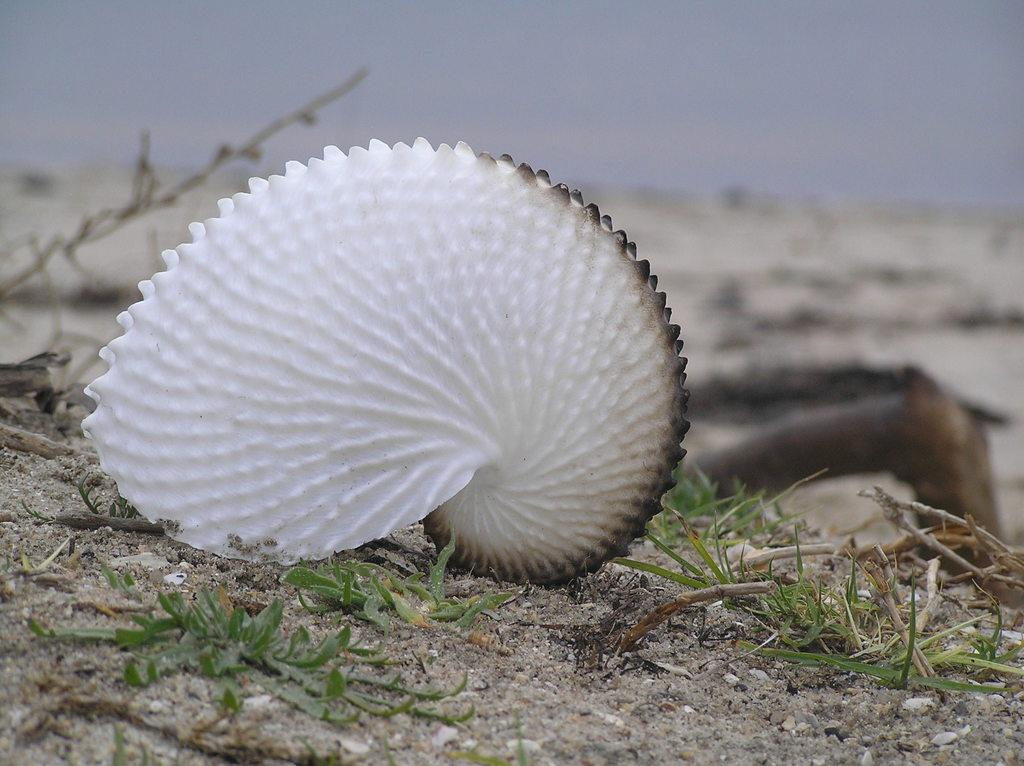What object can be found on the ground in the image? There is a sea shell on the ground in the image. What else can be found on the ground in the image? There are leaves of a plant on the ground in the image. Can you describe the background of the image? The background of the image is blurred. What type of tail can be seen on the sea shell in the image? There is no tail present on the sea shell in the image. How much payment is required to obtain the sea shell in the image? There is no indication of payment or any transaction related to the sea shell in the image. 